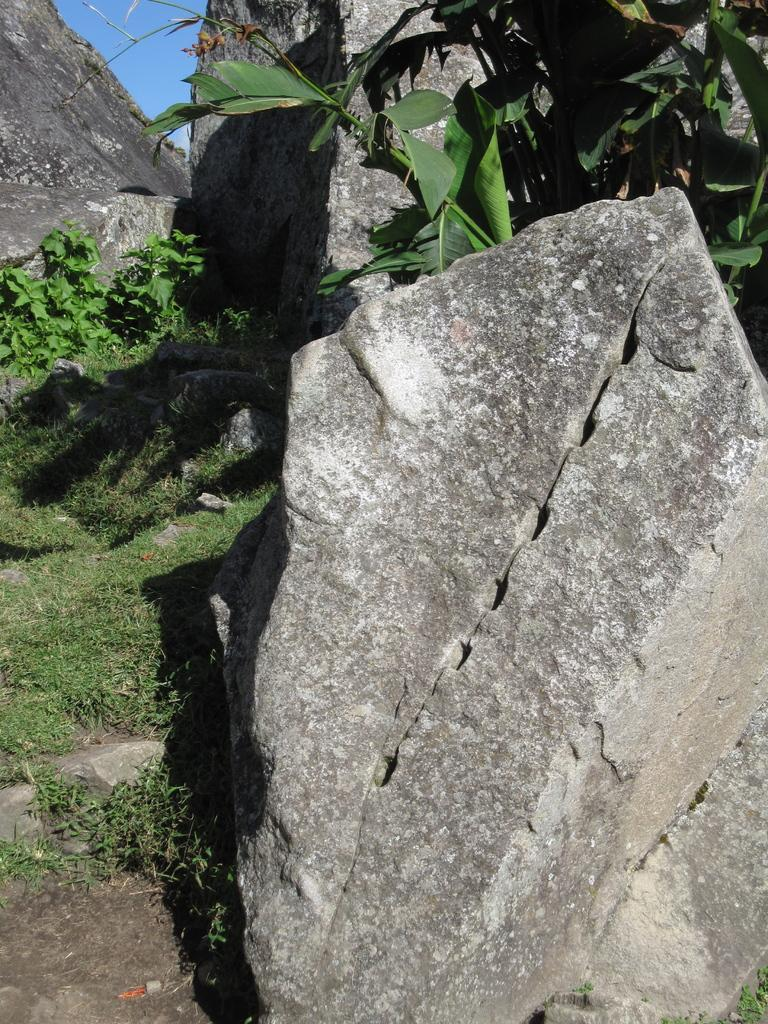What type of natural elements can be seen in the image? There are rocks, grass, and plants visible in the image. Can you describe the vegetation in the image? The image contains grass and various plants. What is the primary difference between the rocks and the plants in the image? The rocks are inanimate, while the plants are living organisms. What type of celery is being used as a decorative element in the image? There is no celery present in the image; it features rocks, grass, and plants. 